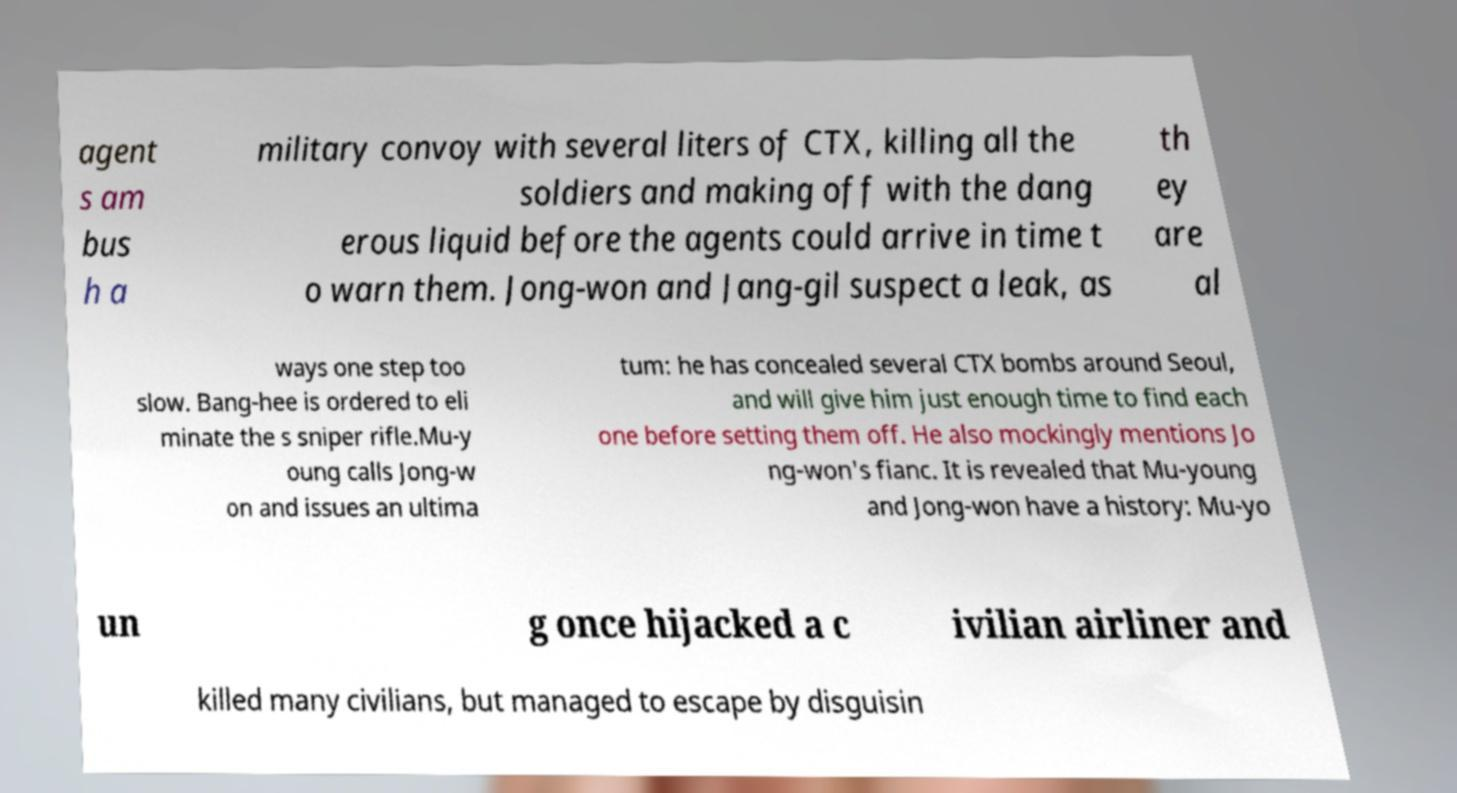Can you read and provide the text displayed in the image?This photo seems to have some interesting text. Can you extract and type it out for me? agent s am bus h a military convoy with several liters of CTX, killing all the soldiers and making off with the dang erous liquid before the agents could arrive in time t o warn them. Jong-won and Jang-gil suspect a leak, as th ey are al ways one step too slow. Bang-hee is ordered to eli minate the s sniper rifle.Mu-y oung calls Jong-w on and issues an ultima tum: he has concealed several CTX bombs around Seoul, and will give him just enough time to find each one before setting them off. He also mockingly mentions Jo ng-won's fianc. It is revealed that Mu-young and Jong-won have a history: Mu-yo un g once hijacked a c ivilian airliner and killed many civilians, but managed to escape by disguisin 